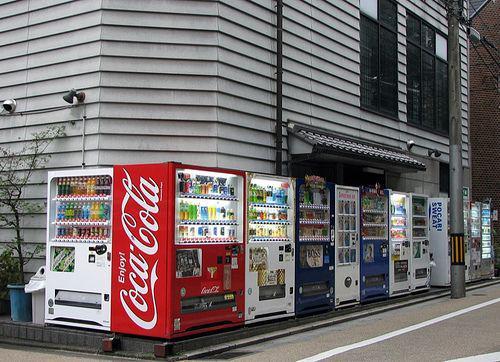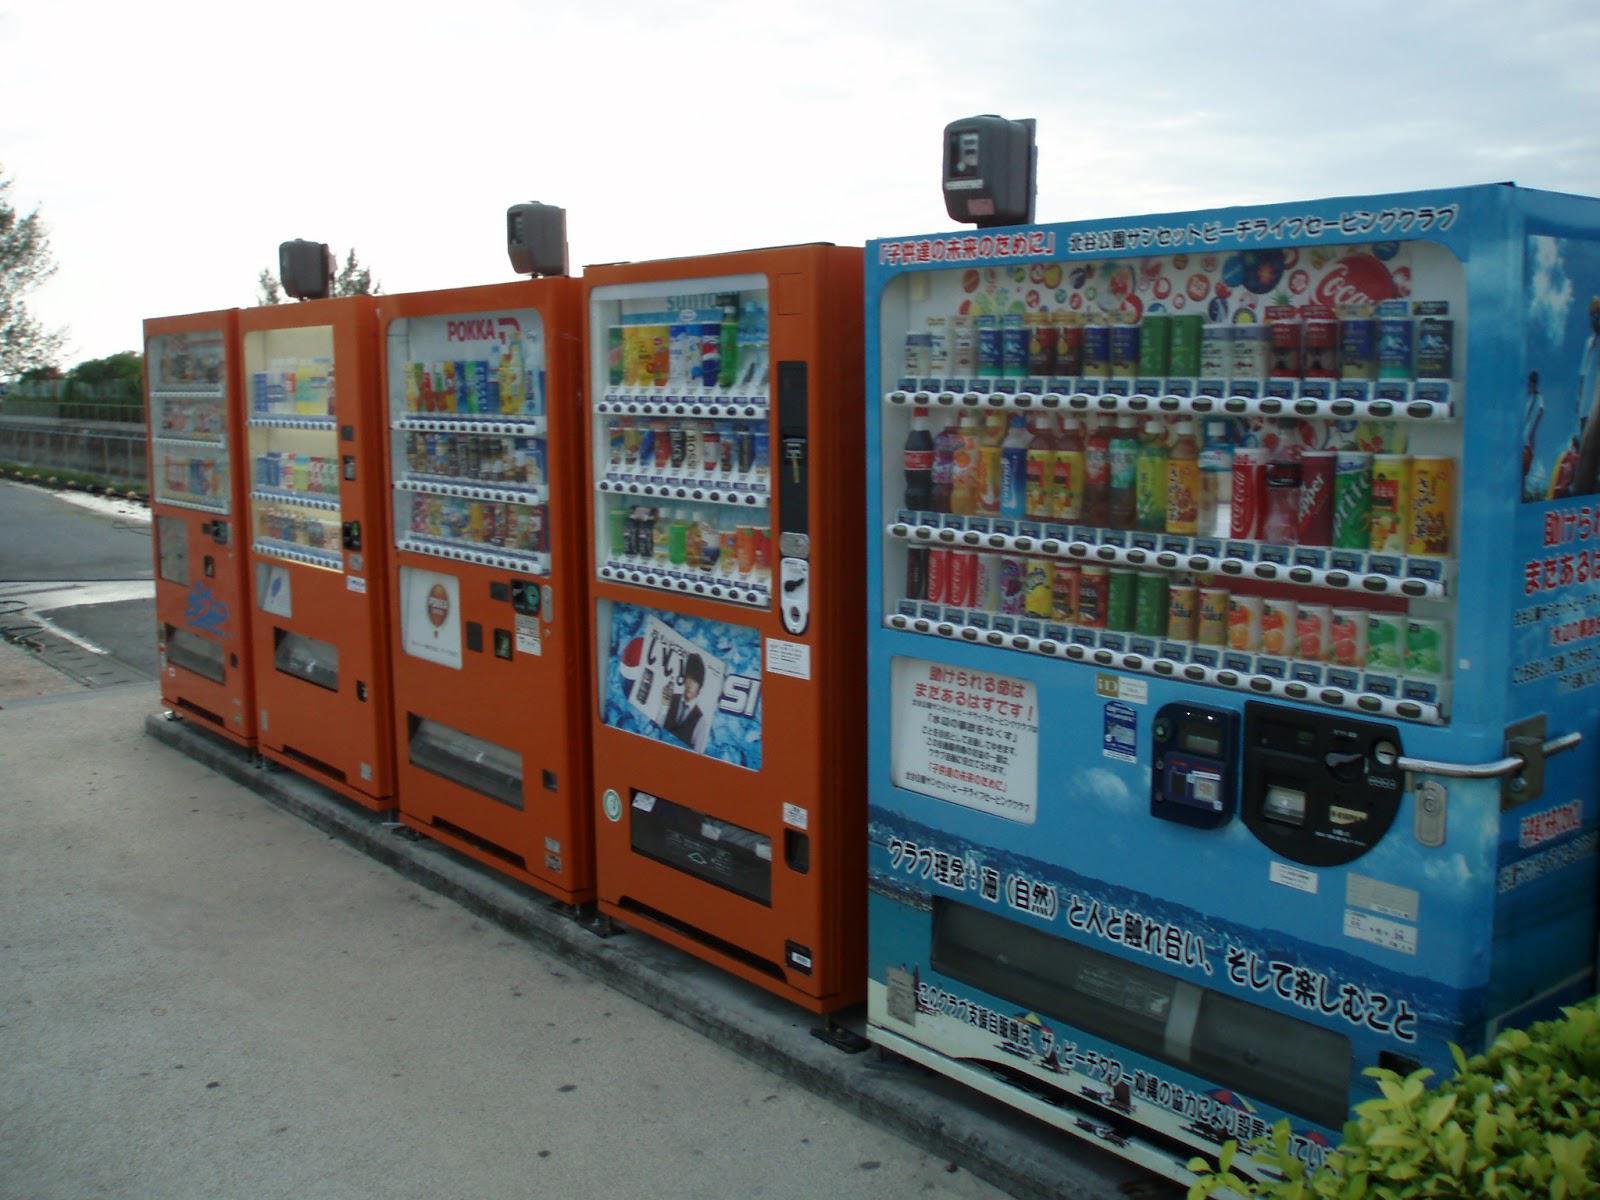The first image is the image on the left, the second image is the image on the right. Analyze the images presented: Is the assertion "An image shows a row of red, white and blue vending machines." valid? Answer yes or no. Yes. The first image is the image on the left, the second image is the image on the right. For the images shown, is this caption "There are at least three vending machines that have blue casing." true? Answer yes or no. Yes. 